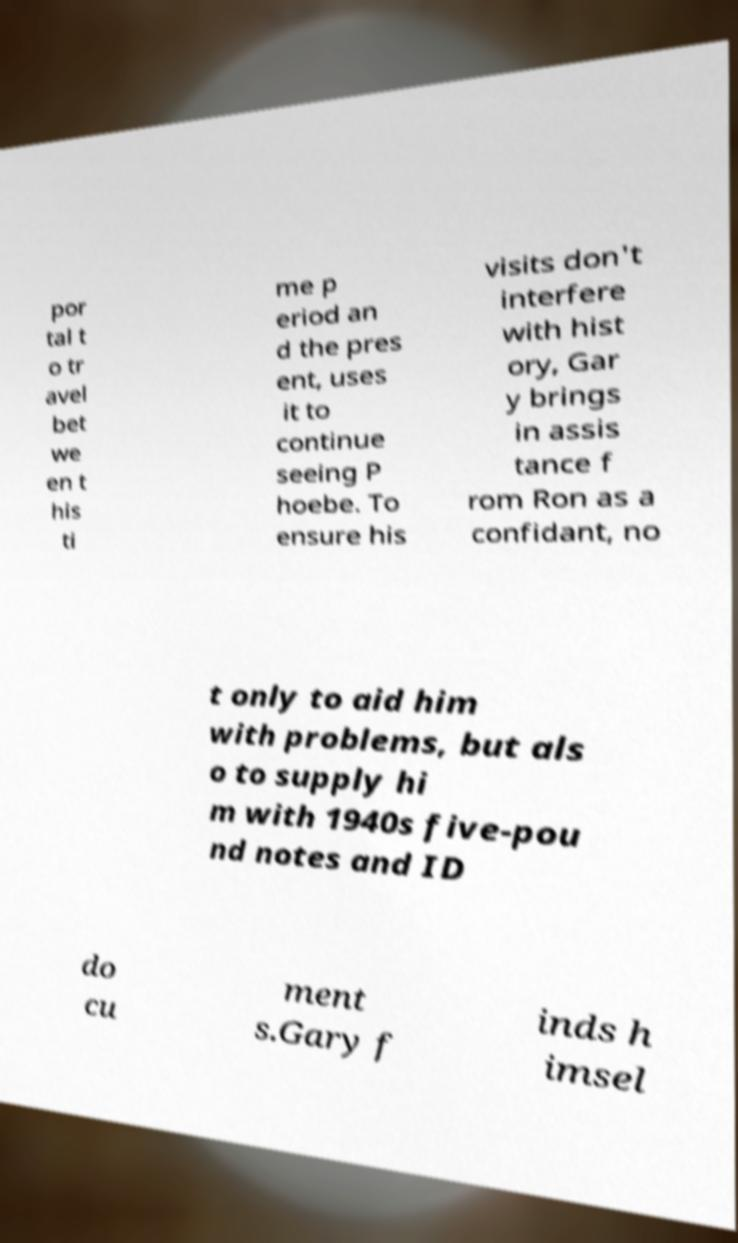Please read and relay the text visible in this image. What does it say? por tal t o tr avel bet we en t his ti me p eriod an d the pres ent, uses it to continue seeing P hoebe. To ensure his visits don't interfere with hist ory, Gar y brings in assis tance f rom Ron as a confidant, no t only to aid him with problems, but als o to supply hi m with 1940s five-pou nd notes and ID do cu ment s.Gary f inds h imsel 